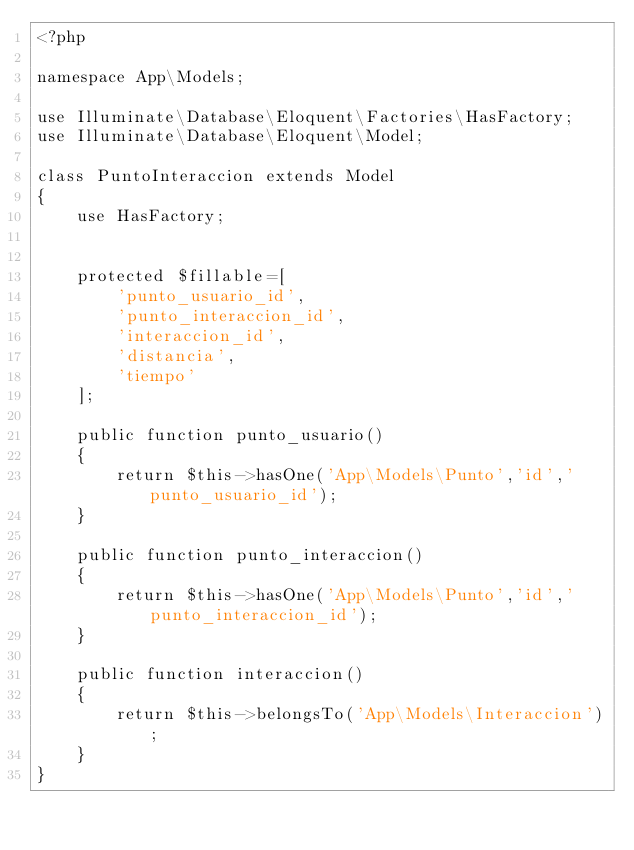Convert code to text. <code><loc_0><loc_0><loc_500><loc_500><_PHP_><?php

namespace App\Models;

use Illuminate\Database\Eloquent\Factories\HasFactory;
use Illuminate\Database\Eloquent\Model;

class PuntoInteraccion extends Model
{
    use HasFactory;


    protected $fillable=[
        'punto_usuario_id',
        'punto_interaccion_id',
        'interaccion_id',
        'distancia',
        'tiempo'
    ];

    public function punto_usuario()
    {
        return $this->hasOne('App\Models\Punto','id','punto_usuario_id');
    }

    public function punto_interaccion()
    {
        return $this->hasOne('App\Models\Punto','id','punto_interaccion_id');
    }

    public function interaccion()
    {
        return $this->belongsTo('App\Models\Interaccion');
    }
}
</code> 